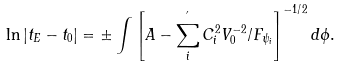<formula> <loc_0><loc_0><loc_500><loc_500>\ln \left | t _ { E } - t _ { 0 } \right | = \pm \int \left [ A - \sum _ { i } ^ { ^ { \prime } } C _ { i } ^ { 2 } V _ { 0 } ^ { - 2 } / F _ { \psi _ { i } } \right ] ^ { - 1 / 2 } d \phi .</formula> 